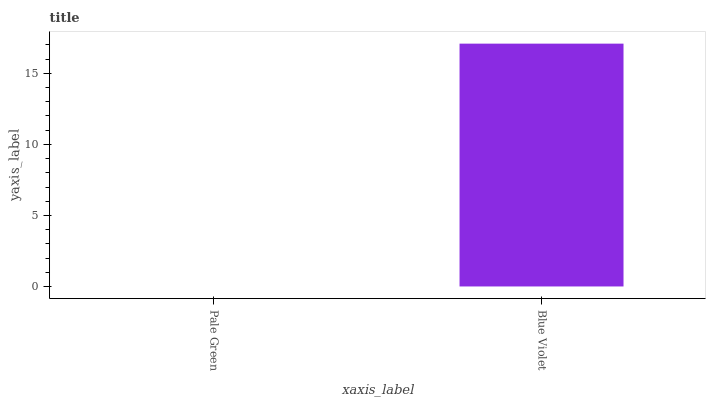Is Pale Green the minimum?
Answer yes or no. Yes. Is Blue Violet the maximum?
Answer yes or no. Yes. Is Blue Violet the minimum?
Answer yes or no. No. Is Blue Violet greater than Pale Green?
Answer yes or no. Yes. Is Pale Green less than Blue Violet?
Answer yes or no. Yes. Is Pale Green greater than Blue Violet?
Answer yes or no. No. Is Blue Violet less than Pale Green?
Answer yes or no. No. Is Blue Violet the high median?
Answer yes or no. Yes. Is Pale Green the low median?
Answer yes or no. Yes. Is Pale Green the high median?
Answer yes or no. No. Is Blue Violet the low median?
Answer yes or no. No. 